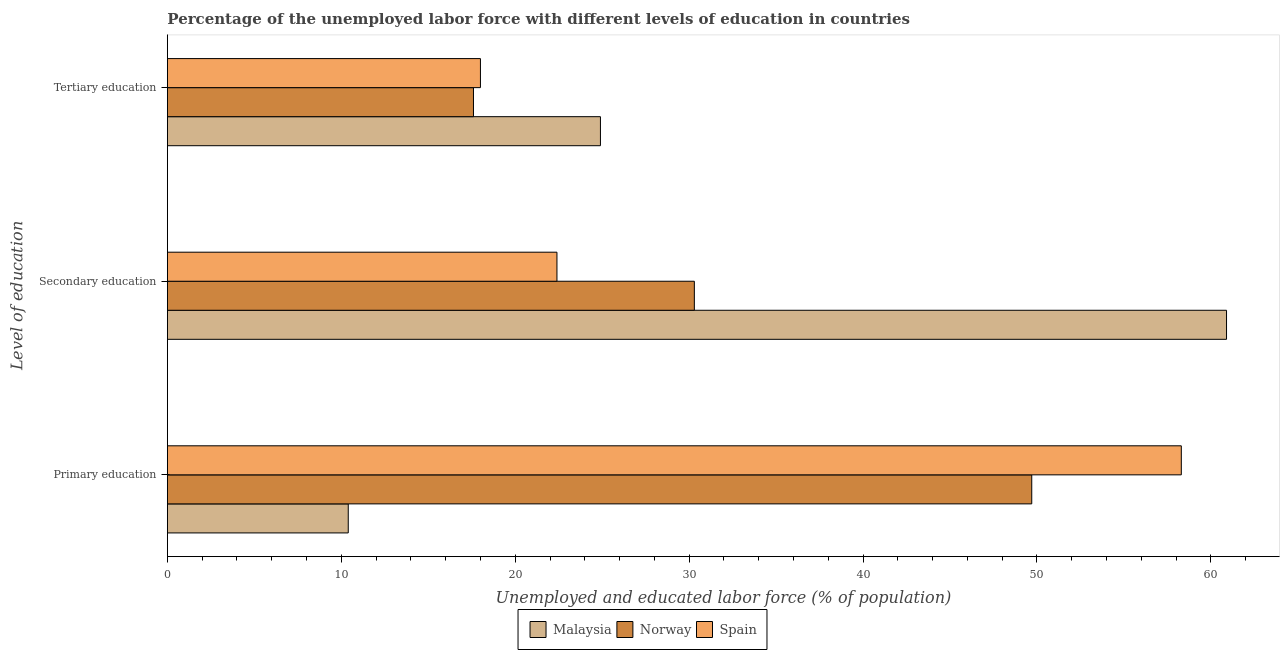Are the number of bars per tick equal to the number of legend labels?
Offer a terse response. Yes. Are the number of bars on each tick of the Y-axis equal?
Give a very brief answer. Yes. How many bars are there on the 1st tick from the top?
Keep it short and to the point. 3. What is the label of the 1st group of bars from the top?
Offer a terse response. Tertiary education. What is the percentage of labor force who received primary education in Spain?
Make the answer very short. 58.3. Across all countries, what is the maximum percentage of labor force who received primary education?
Your answer should be very brief. 58.3. Across all countries, what is the minimum percentage of labor force who received tertiary education?
Provide a succinct answer. 17.6. In which country was the percentage of labor force who received tertiary education maximum?
Make the answer very short. Malaysia. What is the total percentage of labor force who received primary education in the graph?
Your response must be concise. 118.4. What is the difference between the percentage of labor force who received tertiary education in Malaysia and that in Norway?
Give a very brief answer. 7.3. What is the difference between the percentage of labor force who received secondary education in Malaysia and the percentage of labor force who received tertiary education in Norway?
Offer a very short reply. 43.3. What is the average percentage of labor force who received tertiary education per country?
Offer a terse response. 20.17. What is the difference between the percentage of labor force who received secondary education and percentage of labor force who received tertiary education in Malaysia?
Your response must be concise. 36. What is the ratio of the percentage of labor force who received primary education in Spain to that in Malaysia?
Your answer should be compact. 5.61. What is the difference between the highest and the second highest percentage of labor force who received tertiary education?
Keep it short and to the point. 6.9. What is the difference between the highest and the lowest percentage of labor force who received tertiary education?
Provide a short and direct response. 7.3. In how many countries, is the percentage of labor force who received primary education greater than the average percentage of labor force who received primary education taken over all countries?
Your answer should be compact. 2. Is the sum of the percentage of labor force who received primary education in Norway and Malaysia greater than the maximum percentage of labor force who received tertiary education across all countries?
Ensure brevity in your answer.  Yes. What does the 3rd bar from the top in Secondary education represents?
Your answer should be very brief. Malaysia. What does the 1st bar from the bottom in Secondary education represents?
Your response must be concise. Malaysia. Is it the case that in every country, the sum of the percentage of labor force who received primary education and percentage of labor force who received secondary education is greater than the percentage of labor force who received tertiary education?
Your response must be concise. Yes. Are all the bars in the graph horizontal?
Make the answer very short. Yes. How many countries are there in the graph?
Provide a short and direct response. 3. Are the values on the major ticks of X-axis written in scientific E-notation?
Your answer should be compact. No. What is the title of the graph?
Provide a succinct answer. Percentage of the unemployed labor force with different levels of education in countries. What is the label or title of the X-axis?
Your response must be concise. Unemployed and educated labor force (% of population). What is the label or title of the Y-axis?
Offer a terse response. Level of education. What is the Unemployed and educated labor force (% of population) of Malaysia in Primary education?
Your response must be concise. 10.4. What is the Unemployed and educated labor force (% of population) of Norway in Primary education?
Provide a succinct answer. 49.7. What is the Unemployed and educated labor force (% of population) in Spain in Primary education?
Offer a very short reply. 58.3. What is the Unemployed and educated labor force (% of population) in Malaysia in Secondary education?
Provide a succinct answer. 60.9. What is the Unemployed and educated labor force (% of population) of Norway in Secondary education?
Provide a short and direct response. 30.3. What is the Unemployed and educated labor force (% of population) in Spain in Secondary education?
Offer a very short reply. 22.4. What is the Unemployed and educated labor force (% of population) of Malaysia in Tertiary education?
Your response must be concise. 24.9. What is the Unemployed and educated labor force (% of population) in Norway in Tertiary education?
Your answer should be very brief. 17.6. What is the Unemployed and educated labor force (% of population) in Spain in Tertiary education?
Give a very brief answer. 18. Across all Level of education, what is the maximum Unemployed and educated labor force (% of population) in Malaysia?
Provide a short and direct response. 60.9. Across all Level of education, what is the maximum Unemployed and educated labor force (% of population) of Norway?
Offer a very short reply. 49.7. Across all Level of education, what is the maximum Unemployed and educated labor force (% of population) in Spain?
Provide a short and direct response. 58.3. Across all Level of education, what is the minimum Unemployed and educated labor force (% of population) of Malaysia?
Make the answer very short. 10.4. Across all Level of education, what is the minimum Unemployed and educated labor force (% of population) in Norway?
Provide a succinct answer. 17.6. Across all Level of education, what is the minimum Unemployed and educated labor force (% of population) of Spain?
Ensure brevity in your answer.  18. What is the total Unemployed and educated labor force (% of population) in Malaysia in the graph?
Keep it short and to the point. 96.2. What is the total Unemployed and educated labor force (% of population) in Norway in the graph?
Make the answer very short. 97.6. What is the total Unemployed and educated labor force (% of population) in Spain in the graph?
Your response must be concise. 98.7. What is the difference between the Unemployed and educated labor force (% of population) in Malaysia in Primary education and that in Secondary education?
Keep it short and to the point. -50.5. What is the difference between the Unemployed and educated labor force (% of population) of Spain in Primary education and that in Secondary education?
Offer a terse response. 35.9. What is the difference between the Unemployed and educated labor force (% of population) in Norway in Primary education and that in Tertiary education?
Give a very brief answer. 32.1. What is the difference between the Unemployed and educated labor force (% of population) of Spain in Primary education and that in Tertiary education?
Your response must be concise. 40.3. What is the difference between the Unemployed and educated labor force (% of population) in Malaysia in Secondary education and that in Tertiary education?
Make the answer very short. 36. What is the difference between the Unemployed and educated labor force (% of population) in Malaysia in Primary education and the Unemployed and educated labor force (% of population) in Norway in Secondary education?
Make the answer very short. -19.9. What is the difference between the Unemployed and educated labor force (% of population) of Malaysia in Primary education and the Unemployed and educated labor force (% of population) of Spain in Secondary education?
Keep it short and to the point. -12. What is the difference between the Unemployed and educated labor force (% of population) in Norway in Primary education and the Unemployed and educated labor force (% of population) in Spain in Secondary education?
Give a very brief answer. 27.3. What is the difference between the Unemployed and educated labor force (% of population) in Malaysia in Primary education and the Unemployed and educated labor force (% of population) in Norway in Tertiary education?
Offer a terse response. -7.2. What is the difference between the Unemployed and educated labor force (% of population) in Malaysia in Primary education and the Unemployed and educated labor force (% of population) in Spain in Tertiary education?
Your response must be concise. -7.6. What is the difference between the Unemployed and educated labor force (% of population) of Norway in Primary education and the Unemployed and educated labor force (% of population) of Spain in Tertiary education?
Your answer should be very brief. 31.7. What is the difference between the Unemployed and educated labor force (% of population) of Malaysia in Secondary education and the Unemployed and educated labor force (% of population) of Norway in Tertiary education?
Keep it short and to the point. 43.3. What is the difference between the Unemployed and educated labor force (% of population) of Malaysia in Secondary education and the Unemployed and educated labor force (% of population) of Spain in Tertiary education?
Make the answer very short. 42.9. What is the difference between the Unemployed and educated labor force (% of population) in Norway in Secondary education and the Unemployed and educated labor force (% of population) in Spain in Tertiary education?
Your response must be concise. 12.3. What is the average Unemployed and educated labor force (% of population) in Malaysia per Level of education?
Your answer should be compact. 32.07. What is the average Unemployed and educated labor force (% of population) of Norway per Level of education?
Provide a short and direct response. 32.53. What is the average Unemployed and educated labor force (% of population) of Spain per Level of education?
Offer a very short reply. 32.9. What is the difference between the Unemployed and educated labor force (% of population) of Malaysia and Unemployed and educated labor force (% of population) of Norway in Primary education?
Your answer should be compact. -39.3. What is the difference between the Unemployed and educated labor force (% of population) of Malaysia and Unemployed and educated labor force (% of population) of Spain in Primary education?
Provide a succinct answer. -47.9. What is the difference between the Unemployed and educated labor force (% of population) of Malaysia and Unemployed and educated labor force (% of population) of Norway in Secondary education?
Keep it short and to the point. 30.6. What is the difference between the Unemployed and educated labor force (% of population) of Malaysia and Unemployed and educated labor force (% of population) of Spain in Secondary education?
Make the answer very short. 38.5. What is the difference between the Unemployed and educated labor force (% of population) in Norway and Unemployed and educated labor force (% of population) in Spain in Secondary education?
Provide a short and direct response. 7.9. What is the difference between the Unemployed and educated labor force (% of population) of Malaysia and Unemployed and educated labor force (% of population) of Norway in Tertiary education?
Offer a terse response. 7.3. What is the difference between the Unemployed and educated labor force (% of population) of Malaysia and Unemployed and educated labor force (% of population) of Spain in Tertiary education?
Keep it short and to the point. 6.9. What is the difference between the Unemployed and educated labor force (% of population) of Norway and Unemployed and educated labor force (% of population) of Spain in Tertiary education?
Your answer should be compact. -0.4. What is the ratio of the Unemployed and educated labor force (% of population) in Malaysia in Primary education to that in Secondary education?
Provide a short and direct response. 0.17. What is the ratio of the Unemployed and educated labor force (% of population) in Norway in Primary education to that in Secondary education?
Ensure brevity in your answer.  1.64. What is the ratio of the Unemployed and educated labor force (% of population) of Spain in Primary education to that in Secondary education?
Ensure brevity in your answer.  2.6. What is the ratio of the Unemployed and educated labor force (% of population) of Malaysia in Primary education to that in Tertiary education?
Provide a short and direct response. 0.42. What is the ratio of the Unemployed and educated labor force (% of population) in Norway in Primary education to that in Tertiary education?
Your response must be concise. 2.82. What is the ratio of the Unemployed and educated labor force (% of population) of Spain in Primary education to that in Tertiary education?
Your response must be concise. 3.24. What is the ratio of the Unemployed and educated labor force (% of population) of Malaysia in Secondary education to that in Tertiary education?
Make the answer very short. 2.45. What is the ratio of the Unemployed and educated labor force (% of population) in Norway in Secondary education to that in Tertiary education?
Provide a short and direct response. 1.72. What is the ratio of the Unemployed and educated labor force (% of population) of Spain in Secondary education to that in Tertiary education?
Your answer should be compact. 1.24. What is the difference between the highest and the second highest Unemployed and educated labor force (% of population) in Spain?
Your response must be concise. 35.9. What is the difference between the highest and the lowest Unemployed and educated labor force (% of population) in Malaysia?
Provide a succinct answer. 50.5. What is the difference between the highest and the lowest Unemployed and educated labor force (% of population) in Norway?
Provide a short and direct response. 32.1. What is the difference between the highest and the lowest Unemployed and educated labor force (% of population) in Spain?
Offer a very short reply. 40.3. 